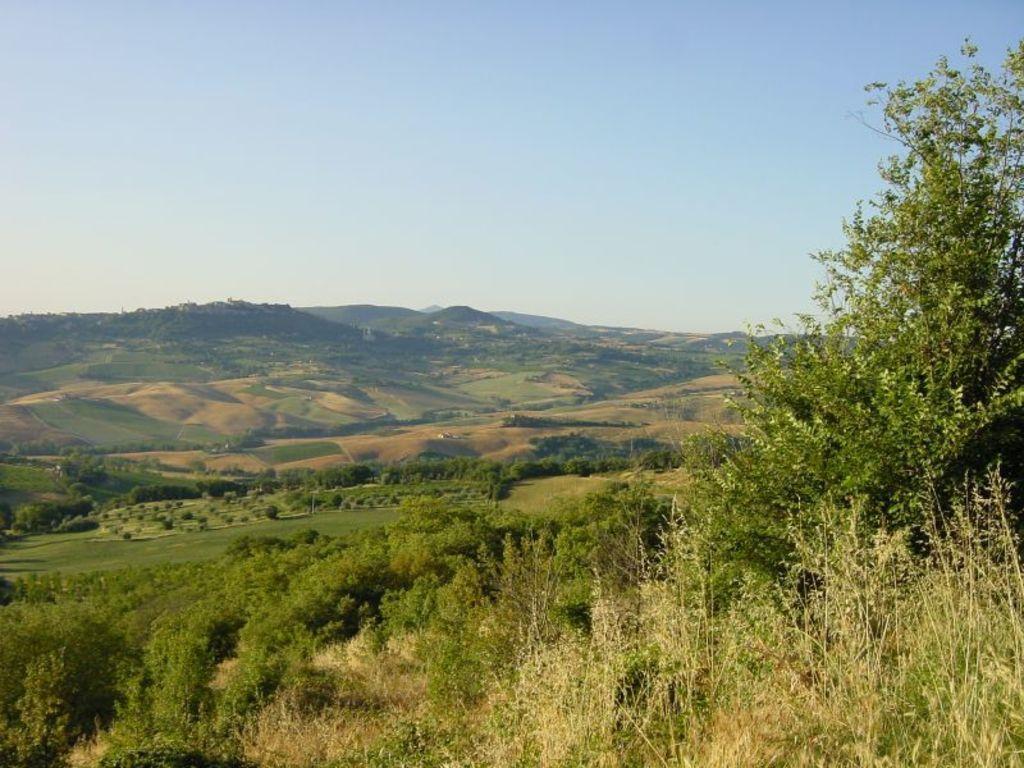In one or two sentences, can you explain what this image depicts? In this image I can see some grass and few trees which are green in color. In the background I can see the ground, few mountains and the sky. 